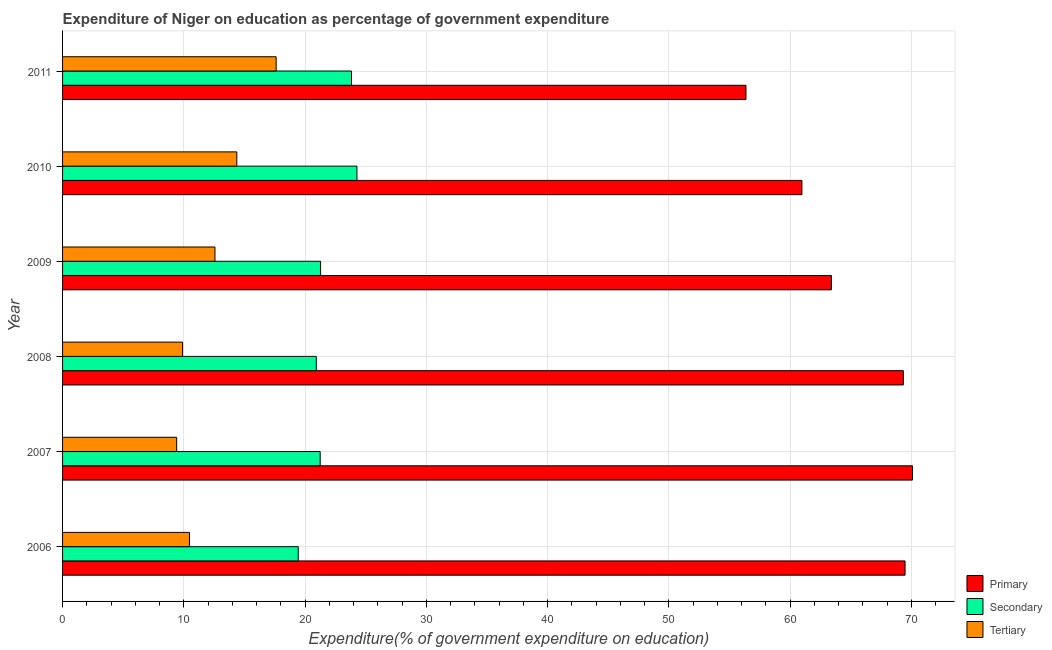Are the number of bars per tick equal to the number of legend labels?
Offer a terse response. Yes. How many bars are there on the 1st tick from the bottom?
Your response must be concise. 3. What is the expenditure on secondary education in 2007?
Your response must be concise. 21.25. Across all years, what is the maximum expenditure on primary education?
Your answer should be very brief. 70.1. Across all years, what is the minimum expenditure on primary education?
Ensure brevity in your answer.  56.36. In which year was the expenditure on primary education minimum?
Provide a succinct answer. 2011. What is the total expenditure on secondary education in the graph?
Your answer should be very brief. 131. What is the difference between the expenditure on secondary education in 2007 and that in 2010?
Your answer should be very brief. -3.03. What is the difference between the expenditure on secondary education in 2006 and the expenditure on primary education in 2010?
Offer a very short reply. -41.54. What is the average expenditure on tertiary education per year?
Provide a short and direct response. 12.39. In the year 2011, what is the difference between the expenditure on secondary education and expenditure on primary education?
Keep it short and to the point. -32.53. In how many years, is the expenditure on tertiary education greater than 38 %?
Give a very brief answer. 0. What is the ratio of the expenditure on secondary education in 2007 to that in 2011?
Your response must be concise. 0.89. Is the difference between the expenditure on primary education in 2009 and 2010 greater than the difference between the expenditure on secondary education in 2009 and 2010?
Give a very brief answer. Yes. What is the difference between the highest and the second highest expenditure on secondary education?
Keep it short and to the point. 0.45. What is the difference between the highest and the lowest expenditure on tertiary education?
Keep it short and to the point. 8.2. Is the sum of the expenditure on primary education in 2006 and 2007 greater than the maximum expenditure on tertiary education across all years?
Offer a very short reply. Yes. What does the 1st bar from the top in 2006 represents?
Keep it short and to the point. Tertiary. What does the 3rd bar from the bottom in 2009 represents?
Provide a short and direct response. Tertiary. Is it the case that in every year, the sum of the expenditure on primary education and expenditure on secondary education is greater than the expenditure on tertiary education?
Offer a terse response. Yes. How many bars are there?
Provide a short and direct response. 18. Are all the bars in the graph horizontal?
Offer a terse response. Yes. What is the difference between two consecutive major ticks on the X-axis?
Ensure brevity in your answer.  10. Are the values on the major ticks of X-axis written in scientific E-notation?
Make the answer very short. No. How many legend labels are there?
Your response must be concise. 3. How are the legend labels stacked?
Keep it short and to the point. Vertical. What is the title of the graph?
Give a very brief answer. Expenditure of Niger on education as percentage of government expenditure. What is the label or title of the X-axis?
Give a very brief answer. Expenditure(% of government expenditure on education). What is the Expenditure(% of government expenditure on education) of Primary in 2006?
Make the answer very short. 69.48. What is the Expenditure(% of government expenditure on education) of Secondary in 2006?
Give a very brief answer. 19.44. What is the Expenditure(% of government expenditure on education) of Tertiary in 2006?
Your response must be concise. 10.47. What is the Expenditure(% of government expenditure on education) of Primary in 2007?
Give a very brief answer. 70.1. What is the Expenditure(% of government expenditure on education) of Secondary in 2007?
Provide a short and direct response. 21.25. What is the Expenditure(% of government expenditure on education) of Tertiary in 2007?
Ensure brevity in your answer.  9.41. What is the Expenditure(% of government expenditure on education) in Primary in 2008?
Offer a terse response. 69.34. What is the Expenditure(% of government expenditure on education) in Secondary in 2008?
Ensure brevity in your answer.  20.93. What is the Expenditure(% of government expenditure on education) in Tertiary in 2008?
Provide a succinct answer. 9.9. What is the Expenditure(% of government expenditure on education) of Primary in 2009?
Make the answer very short. 63.41. What is the Expenditure(% of government expenditure on education) in Secondary in 2009?
Keep it short and to the point. 21.28. What is the Expenditure(% of government expenditure on education) of Tertiary in 2009?
Give a very brief answer. 12.57. What is the Expenditure(% of government expenditure on education) in Primary in 2010?
Your answer should be very brief. 60.98. What is the Expenditure(% of government expenditure on education) in Secondary in 2010?
Provide a short and direct response. 24.28. What is the Expenditure(% of government expenditure on education) in Tertiary in 2010?
Make the answer very short. 14.37. What is the Expenditure(% of government expenditure on education) of Primary in 2011?
Keep it short and to the point. 56.36. What is the Expenditure(% of government expenditure on education) in Secondary in 2011?
Your answer should be very brief. 23.83. What is the Expenditure(% of government expenditure on education) in Tertiary in 2011?
Your answer should be very brief. 17.61. Across all years, what is the maximum Expenditure(% of government expenditure on education) in Primary?
Offer a very short reply. 70.1. Across all years, what is the maximum Expenditure(% of government expenditure on education) of Secondary?
Your answer should be very brief. 24.28. Across all years, what is the maximum Expenditure(% of government expenditure on education) in Tertiary?
Provide a short and direct response. 17.61. Across all years, what is the minimum Expenditure(% of government expenditure on education) in Primary?
Offer a terse response. 56.36. Across all years, what is the minimum Expenditure(% of government expenditure on education) in Secondary?
Your answer should be very brief. 19.44. Across all years, what is the minimum Expenditure(% of government expenditure on education) of Tertiary?
Offer a terse response. 9.41. What is the total Expenditure(% of government expenditure on education) in Primary in the graph?
Your answer should be compact. 389.67. What is the total Expenditure(% of government expenditure on education) of Secondary in the graph?
Your answer should be very brief. 131. What is the total Expenditure(% of government expenditure on education) of Tertiary in the graph?
Make the answer very short. 74.33. What is the difference between the Expenditure(% of government expenditure on education) of Primary in 2006 and that in 2007?
Provide a short and direct response. -0.61. What is the difference between the Expenditure(% of government expenditure on education) in Secondary in 2006 and that in 2007?
Your answer should be compact. -1.81. What is the difference between the Expenditure(% of government expenditure on education) in Tertiary in 2006 and that in 2007?
Your answer should be compact. 1.06. What is the difference between the Expenditure(% of government expenditure on education) in Primary in 2006 and that in 2008?
Your answer should be very brief. 0.14. What is the difference between the Expenditure(% of government expenditure on education) of Secondary in 2006 and that in 2008?
Your response must be concise. -1.49. What is the difference between the Expenditure(% of government expenditure on education) of Tertiary in 2006 and that in 2008?
Keep it short and to the point. 0.57. What is the difference between the Expenditure(% of government expenditure on education) of Primary in 2006 and that in 2009?
Your answer should be compact. 6.07. What is the difference between the Expenditure(% of government expenditure on education) of Secondary in 2006 and that in 2009?
Your response must be concise. -1.84. What is the difference between the Expenditure(% of government expenditure on education) in Tertiary in 2006 and that in 2009?
Your response must be concise. -2.1. What is the difference between the Expenditure(% of government expenditure on education) of Primary in 2006 and that in 2010?
Your answer should be compact. 8.51. What is the difference between the Expenditure(% of government expenditure on education) of Secondary in 2006 and that in 2010?
Your answer should be very brief. -4.84. What is the difference between the Expenditure(% of government expenditure on education) of Tertiary in 2006 and that in 2010?
Provide a short and direct response. -3.9. What is the difference between the Expenditure(% of government expenditure on education) of Primary in 2006 and that in 2011?
Make the answer very short. 13.12. What is the difference between the Expenditure(% of government expenditure on education) of Secondary in 2006 and that in 2011?
Your answer should be compact. -4.39. What is the difference between the Expenditure(% of government expenditure on education) in Tertiary in 2006 and that in 2011?
Your answer should be compact. -7.15. What is the difference between the Expenditure(% of government expenditure on education) of Primary in 2007 and that in 2008?
Ensure brevity in your answer.  0.75. What is the difference between the Expenditure(% of government expenditure on education) of Secondary in 2007 and that in 2008?
Offer a very short reply. 0.32. What is the difference between the Expenditure(% of government expenditure on education) of Tertiary in 2007 and that in 2008?
Your answer should be very brief. -0.49. What is the difference between the Expenditure(% of government expenditure on education) of Primary in 2007 and that in 2009?
Keep it short and to the point. 6.68. What is the difference between the Expenditure(% of government expenditure on education) in Secondary in 2007 and that in 2009?
Provide a succinct answer. -0.03. What is the difference between the Expenditure(% of government expenditure on education) in Tertiary in 2007 and that in 2009?
Make the answer very short. -3.16. What is the difference between the Expenditure(% of government expenditure on education) in Primary in 2007 and that in 2010?
Your answer should be compact. 9.12. What is the difference between the Expenditure(% of government expenditure on education) in Secondary in 2007 and that in 2010?
Offer a terse response. -3.03. What is the difference between the Expenditure(% of government expenditure on education) of Tertiary in 2007 and that in 2010?
Make the answer very short. -4.96. What is the difference between the Expenditure(% of government expenditure on education) of Primary in 2007 and that in 2011?
Keep it short and to the point. 13.73. What is the difference between the Expenditure(% of government expenditure on education) of Secondary in 2007 and that in 2011?
Your answer should be very brief. -2.58. What is the difference between the Expenditure(% of government expenditure on education) in Tertiary in 2007 and that in 2011?
Your answer should be very brief. -8.2. What is the difference between the Expenditure(% of government expenditure on education) of Primary in 2008 and that in 2009?
Provide a short and direct response. 5.93. What is the difference between the Expenditure(% of government expenditure on education) of Secondary in 2008 and that in 2009?
Your answer should be compact. -0.35. What is the difference between the Expenditure(% of government expenditure on education) of Tertiary in 2008 and that in 2009?
Offer a very short reply. -2.67. What is the difference between the Expenditure(% of government expenditure on education) in Primary in 2008 and that in 2010?
Give a very brief answer. 8.36. What is the difference between the Expenditure(% of government expenditure on education) in Secondary in 2008 and that in 2010?
Provide a short and direct response. -3.35. What is the difference between the Expenditure(% of government expenditure on education) of Tertiary in 2008 and that in 2010?
Provide a short and direct response. -4.47. What is the difference between the Expenditure(% of government expenditure on education) in Primary in 2008 and that in 2011?
Keep it short and to the point. 12.98. What is the difference between the Expenditure(% of government expenditure on education) in Secondary in 2008 and that in 2011?
Offer a very short reply. -2.9. What is the difference between the Expenditure(% of government expenditure on education) of Tertiary in 2008 and that in 2011?
Keep it short and to the point. -7.72. What is the difference between the Expenditure(% of government expenditure on education) in Primary in 2009 and that in 2010?
Provide a succinct answer. 2.43. What is the difference between the Expenditure(% of government expenditure on education) in Secondary in 2009 and that in 2010?
Give a very brief answer. -3. What is the difference between the Expenditure(% of government expenditure on education) of Tertiary in 2009 and that in 2010?
Offer a very short reply. -1.8. What is the difference between the Expenditure(% of government expenditure on education) in Primary in 2009 and that in 2011?
Give a very brief answer. 7.05. What is the difference between the Expenditure(% of government expenditure on education) in Secondary in 2009 and that in 2011?
Offer a very short reply. -2.55. What is the difference between the Expenditure(% of government expenditure on education) in Tertiary in 2009 and that in 2011?
Offer a terse response. -5.05. What is the difference between the Expenditure(% of government expenditure on education) in Primary in 2010 and that in 2011?
Offer a very short reply. 4.62. What is the difference between the Expenditure(% of government expenditure on education) of Secondary in 2010 and that in 2011?
Provide a succinct answer. 0.45. What is the difference between the Expenditure(% of government expenditure on education) in Tertiary in 2010 and that in 2011?
Offer a terse response. -3.24. What is the difference between the Expenditure(% of government expenditure on education) in Primary in 2006 and the Expenditure(% of government expenditure on education) in Secondary in 2007?
Your answer should be very brief. 48.24. What is the difference between the Expenditure(% of government expenditure on education) in Primary in 2006 and the Expenditure(% of government expenditure on education) in Tertiary in 2007?
Offer a terse response. 60.07. What is the difference between the Expenditure(% of government expenditure on education) in Secondary in 2006 and the Expenditure(% of government expenditure on education) in Tertiary in 2007?
Your answer should be very brief. 10.03. What is the difference between the Expenditure(% of government expenditure on education) of Primary in 2006 and the Expenditure(% of government expenditure on education) of Secondary in 2008?
Your answer should be compact. 48.56. What is the difference between the Expenditure(% of government expenditure on education) in Primary in 2006 and the Expenditure(% of government expenditure on education) in Tertiary in 2008?
Provide a short and direct response. 59.59. What is the difference between the Expenditure(% of government expenditure on education) in Secondary in 2006 and the Expenditure(% of government expenditure on education) in Tertiary in 2008?
Offer a very short reply. 9.54. What is the difference between the Expenditure(% of government expenditure on education) of Primary in 2006 and the Expenditure(% of government expenditure on education) of Secondary in 2009?
Keep it short and to the point. 48.2. What is the difference between the Expenditure(% of government expenditure on education) of Primary in 2006 and the Expenditure(% of government expenditure on education) of Tertiary in 2009?
Offer a terse response. 56.92. What is the difference between the Expenditure(% of government expenditure on education) in Secondary in 2006 and the Expenditure(% of government expenditure on education) in Tertiary in 2009?
Your answer should be very brief. 6.87. What is the difference between the Expenditure(% of government expenditure on education) of Primary in 2006 and the Expenditure(% of government expenditure on education) of Secondary in 2010?
Ensure brevity in your answer.  45.21. What is the difference between the Expenditure(% of government expenditure on education) in Primary in 2006 and the Expenditure(% of government expenditure on education) in Tertiary in 2010?
Make the answer very short. 55.12. What is the difference between the Expenditure(% of government expenditure on education) in Secondary in 2006 and the Expenditure(% of government expenditure on education) in Tertiary in 2010?
Offer a very short reply. 5.07. What is the difference between the Expenditure(% of government expenditure on education) of Primary in 2006 and the Expenditure(% of government expenditure on education) of Secondary in 2011?
Keep it short and to the point. 45.66. What is the difference between the Expenditure(% of government expenditure on education) in Primary in 2006 and the Expenditure(% of government expenditure on education) in Tertiary in 2011?
Your response must be concise. 51.87. What is the difference between the Expenditure(% of government expenditure on education) of Secondary in 2006 and the Expenditure(% of government expenditure on education) of Tertiary in 2011?
Keep it short and to the point. 1.82. What is the difference between the Expenditure(% of government expenditure on education) of Primary in 2007 and the Expenditure(% of government expenditure on education) of Secondary in 2008?
Your answer should be compact. 49.17. What is the difference between the Expenditure(% of government expenditure on education) in Primary in 2007 and the Expenditure(% of government expenditure on education) in Tertiary in 2008?
Offer a terse response. 60.2. What is the difference between the Expenditure(% of government expenditure on education) in Secondary in 2007 and the Expenditure(% of government expenditure on education) in Tertiary in 2008?
Your answer should be very brief. 11.35. What is the difference between the Expenditure(% of government expenditure on education) of Primary in 2007 and the Expenditure(% of government expenditure on education) of Secondary in 2009?
Your response must be concise. 48.82. What is the difference between the Expenditure(% of government expenditure on education) in Primary in 2007 and the Expenditure(% of government expenditure on education) in Tertiary in 2009?
Give a very brief answer. 57.53. What is the difference between the Expenditure(% of government expenditure on education) in Secondary in 2007 and the Expenditure(% of government expenditure on education) in Tertiary in 2009?
Offer a very short reply. 8.68. What is the difference between the Expenditure(% of government expenditure on education) of Primary in 2007 and the Expenditure(% of government expenditure on education) of Secondary in 2010?
Keep it short and to the point. 45.82. What is the difference between the Expenditure(% of government expenditure on education) in Primary in 2007 and the Expenditure(% of government expenditure on education) in Tertiary in 2010?
Keep it short and to the point. 55.73. What is the difference between the Expenditure(% of government expenditure on education) in Secondary in 2007 and the Expenditure(% of government expenditure on education) in Tertiary in 2010?
Ensure brevity in your answer.  6.88. What is the difference between the Expenditure(% of government expenditure on education) in Primary in 2007 and the Expenditure(% of government expenditure on education) in Secondary in 2011?
Keep it short and to the point. 46.27. What is the difference between the Expenditure(% of government expenditure on education) in Primary in 2007 and the Expenditure(% of government expenditure on education) in Tertiary in 2011?
Provide a succinct answer. 52.48. What is the difference between the Expenditure(% of government expenditure on education) of Secondary in 2007 and the Expenditure(% of government expenditure on education) of Tertiary in 2011?
Your answer should be very brief. 3.63. What is the difference between the Expenditure(% of government expenditure on education) of Primary in 2008 and the Expenditure(% of government expenditure on education) of Secondary in 2009?
Keep it short and to the point. 48.06. What is the difference between the Expenditure(% of government expenditure on education) in Primary in 2008 and the Expenditure(% of government expenditure on education) in Tertiary in 2009?
Your answer should be compact. 56.77. What is the difference between the Expenditure(% of government expenditure on education) in Secondary in 2008 and the Expenditure(% of government expenditure on education) in Tertiary in 2009?
Offer a very short reply. 8.36. What is the difference between the Expenditure(% of government expenditure on education) in Primary in 2008 and the Expenditure(% of government expenditure on education) in Secondary in 2010?
Keep it short and to the point. 45.06. What is the difference between the Expenditure(% of government expenditure on education) in Primary in 2008 and the Expenditure(% of government expenditure on education) in Tertiary in 2010?
Your response must be concise. 54.97. What is the difference between the Expenditure(% of government expenditure on education) of Secondary in 2008 and the Expenditure(% of government expenditure on education) of Tertiary in 2010?
Your answer should be very brief. 6.56. What is the difference between the Expenditure(% of government expenditure on education) of Primary in 2008 and the Expenditure(% of government expenditure on education) of Secondary in 2011?
Offer a terse response. 45.51. What is the difference between the Expenditure(% of government expenditure on education) of Primary in 2008 and the Expenditure(% of government expenditure on education) of Tertiary in 2011?
Make the answer very short. 51.73. What is the difference between the Expenditure(% of government expenditure on education) of Secondary in 2008 and the Expenditure(% of government expenditure on education) of Tertiary in 2011?
Give a very brief answer. 3.31. What is the difference between the Expenditure(% of government expenditure on education) in Primary in 2009 and the Expenditure(% of government expenditure on education) in Secondary in 2010?
Ensure brevity in your answer.  39.13. What is the difference between the Expenditure(% of government expenditure on education) in Primary in 2009 and the Expenditure(% of government expenditure on education) in Tertiary in 2010?
Ensure brevity in your answer.  49.04. What is the difference between the Expenditure(% of government expenditure on education) in Secondary in 2009 and the Expenditure(% of government expenditure on education) in Tertiary in 2010?
Ensure brevity in your answer.  6.91. What is the difference between the Expenditure(% of government expenditure on education) of Primary in 2009 and the Expenditure(% of government expenditure on education) of Secondary in 2011?
Give a very brief answer. 39.58. What is the difference between the Expenditure(% of government expenditure on education) of Primary in 2009 and the Expenditure(% of government expenditure on education) of Tertiary in 2011?
Ensure brevity in your answer.  45.8. What is the difference between the Expenditure(% of government expenditure on education) of Secondary in 2009 and the Expenditure(% of government expenditure on education) of Tertiary in 2011?
Offer a terse response. 3.67. What is the difference between the Expenditure(% of government expenditure on education) of Primary in 2010 and the Expenditure(% of government expenditure on education) of Secondary in 2011?
Give a very brief answer. 37.15. What is the difference between the Expenditure(% of government expenditure on education) of Primary in 2010 and the Expenditure(% of government expenditure on education) of Tertiary in 2011?
Your answer should be compact. 43.36. What is the difference between the Expenditure(% of government expenditure on education) in Secondary in 2010 and the Expenditure(% of government expenditure on education) in Tertiary in 2011?
Your answer should be very brief. 6.66. What is the average Expenditure(% of government expenditure on education) of Primary per year?
Make the answer very short. 64.95. What is the average Expenditure(% of government expenditure on education) in Secondary per year?
Your answer should be compact. 21.83. What is the average Expenditure(% of government expenditure on education) in Tertiary per year?
Your answer should be compact. 12.39. In the year 2006, what is the difference between the Expenditure(% of government expenditure on education) in Primary and Expenditure(% of government expenditure on education) in Secondary?
Make the answer very short. 50.05. In the year 2006, what is the difference between the Expenditure(% of government expenditure on education) in Primary and Expenditure(% of government expenditure on education) in Tertiary?
Offer a very short reply. 59.02. In the year 2006, what is the difference between the Expenditure(% of government expenditure on education) of Secondary and Expenditure(% of government expenditure on education) of Tertiary?
Ensure brevity in your answer.  8.97. In the year 2007, what is the difference between the Expenditure(% of government expenditure on education) of Primary and Expenditure(% of government expenditure on education) of Secondary?
Provide a short and direct response. 48.85. In the year 2007, what is the difference between the Expenditure(% of government expenditure on education) of Primary and Expenditure(% of government expenditure on education) of Tertiary?
Offer a very short reply. 60.68. In the year 2007, what is the difference between the Expenditure(% of government expenditure on education) of Secondary and Expenditure(% of government expenditure on education) of Tertiary?
Ensure brevity in your answer.  11.84. In the year 2008, what is the difference between the Expenditure(% of government expenditure on education) of Primary and Expenditure(% of government expenditure on education) of Secondary?
Ensure brevity in your answer.  48.42. In the year 2008, what is the difference between the Expenditure(% of government expenditure on education) in Primary and Expenditure(% of government expenditure on education) in Tertiary?
Give a very brief answer. 59.44. In the year 2008, what is the difference between the Expenditure(% of government expenditure on education) of Secondary and Expenditure(% of government expenditure on education) of Tertiary?
Ensure brevity in your answer.  11.03. In the year 2009, what is the difference between the Expenditure(% of government expenditure on education) of Primary and Expenditure(% of government expenditure on education) of Secondary?
Give a very brief answer. 42.13. In the year 2009, what is the difference between the Expenditure(% of government expenditure on education) in Primary and Expenditure(% of government expenditure on education) in Tertiary?
Offer a very short reply. 50.84. In the year 2009, what is the difference between the Expenditure(% of government expenditure on education) of Secondary and Expenditure(% of government expenditure on education) of Tertiary?
Provide a succinct answer. 8.71. In the year 2010, what is the difference between the Expenditure(% of government expenditure on education) in Primary and Expenditure(% of government expenditure on education) in Secondary?
Offer a terse response. 36.7. In the year 2010, what is the difference between the Expenditure(% of government expenditure on education) in Primary and Expenditure(% of government expenditure on education) in Tertiary?
Keep it short and to the point. 46.61. In the year 2010, what is the difference between the Expenditure(% of government expenditure on education) of Secondary and Expenditure(% of government expenditure on education) of Tertiary?
Keep it short and to the point. 9.91. In the year 2011, what is the difference between the Expenditure(% of government expenditure on education) of Primary and Expenditure(% of government expenditure on education) of Secondary?
Ensure brevity in your answer.  32.53. In the year 2011, what is the difference between the Expenditure(% of government expenditure on education) of Primary and Expenditure(% of government expenditure on education) of Tertiary?
Your answer should be compact. 38.75. In the year 2011, what is the difference between the Expenditure(% of government expenditure on education) in Secondary and Expenditure(% of government expenditure on education) in Tertiary?
Provide a short and direct response. 6.22. What is the ratio of the Expenditure(% of government expenditure on education) in Primary in 2006 to that in 2007?
Give a very brief answer. 0.99. What is the ratio of the Expenditure(% of government expenditure on education) in Secondary in 2006 to that in 2007?
Your answer should be very brief. 0.91. What is the ratio of the Expenditure(% of government expenditure on education) of Tertiary in 2006 to that in 2007?
Offer a very short reply. 1.11. What is the ratio of the Expenditure(% of government expenditure on education) in Primary in 2006 to that in 2008?
Provide a succinct answer. 1. What is the ratio of the Expenditure(% of government expenditure on education) of Secondary in 2006 to that in 2008?
Keep it short and to the point. 0.93. What is the ratio of the Expenditure(% of government expenditure on education) of Tertiary in 2006 to that in 2008?
Your response must be concise. 1.06. What is the ratio of the Expenditure(% of government expenditure on education) in Primary in 2006 to that in 2009?
Keep it short and to the point. 1.1. What is the ratio of the Expenditure(% of government expenditure on education) in Secondary in 2006 to that in 2009?
Make the answer very short. 0.91. What is the ratio of the Expenditure(% of government expenditure on education) in Tertiary in 2006 to that in 2009?
Ensure brevity in your answer.  0.83. What is the ratio of the Expenditure(% of government expenditure on education) of Primary in 2006 to that in 2010?
Offer a terse response. 1.14. What is the ratio of the Expenditure(% of government expenditure on education) in Secondary in 2006 to that in 2010?
Make the answer very short. 0.8. What is the ratio of the Expenditure(% of government expenditure on education) in Tertiary in 2006 to that in 2010?
Keep it short and to the point. 0.73. What is the ratio of the Expenditure(% of government expenditure on education) of Primary in 2006 to that in 2011?
Your answer should be compact. 1.23. What is the ratio of the Expenditure(% of government expenditure on education) of Secondary in 2006 to that in 2011?
Provide a short and direct response. 0.82. What is the ratio of the Expenditure(% of government expenditure on education) of Tertiary in 2006 to that in 2011?
Your answer should be very brief. 0.59. What is the ratio of the Expenditure(% of government expenditure on education) in Primary in 2007 to that in 2008?
Provide a short and direct response. 1.01. What is the ratio of the Expenditure(% of government expenditure on education) in Secondary in 2007 to that in 2008?
Offer a very short reply. 1.02. What is the ratio of the Expenditure(% of government expenditure on education) in Tertiary in 2007 to that in 2008?
Provide a short and direct response. 0.95. What is the ratio of the Expenditure(% of government expenditure on education) in Primary in 2007 to that in 2009?
Provide a short and direct response. 1.11. What is the ratio of the Expenditure(% of government expenditure on education) in Tertiary in 2007 to that in 2009?
Provide a short and direct response. 0.75. What is the ratio of the Expenditure(% of government expenditure on education) in Primary in 2007 to that in 2010?
Make the answer very short. 1.15. What is the ratio of the Expenditure(% of government expenditure on education) in Secondary in 2007 to that in 2010?
Provide a succinct answer. 0.88. What is the ratio of the Expenditure(% of government expenditure on education) in Tertiary in 2007 to that in 2010?
Keep it short and to the point. 0.65. What is the ratio of the Expenditure(% of government expenditure on education) in Primary in 2007 to that in 2011?
Your answer should be very brief. 1.24. What is the ratio of the Expenditure(% of government expenditure on education) in Secondary in 2007 to that in 2011?
Provide a short and direct response. 0.89. What is the ratio of the Expenditure(% of government expenditure on education) in Tertiary in 2007 to that in 2011?
Your answer should be very brief. 0.53. What is the ratio of the Expenditure(% of government expenditure on education) in Primary in 2008 to that in 2009?
Offer a very short reply. 1.09. What is the ratio of the Expenditure(% of government expenditure on education) of Secondary in 2008 to that in 2009?
Offer a terse response. 0.98. What is the ratio of the Expenditure(% of government expenditure on education) in Tertiary in 2008 to that in 2009?
Your answer should be compact. 0.79. What is the ratio of the Expenditure(% of government expenditure on education) in Primary in 2008 to that in 2010?
Your answer should be compact. 1.14. What is the ratio of the Expenditure(% of government expenditure on education) in Secondary in 2008 to that in 2010?
Ensure brevity in your answer.  0.86. What is the ratio of the Expenditure(% of government expenditure on education) of Tertiary in 2008 to that in 2010?
Offer a terse response. 0.69. What is the ratio of the Expenditure(% of government expenditure on education) in Primary in 2008 to that in 2011?
Offer a very short reply. 1.23. What is the ratio of the Expenditure(% of government expenditure on education) in Secondary in 2008 to that in 2011?
Provide a short and direct response. 0.88. What is the ratio of the Expenditure(% of government expenditure on education) of Tertiary in 2008 to that in 2011?
Keep it short and to the point. 0.56. What is the ratio of the Expenditure(% of government expenditure on education) in Primary in 2009 to that in 2010?
Make the answer very short. 1.04. What is the ratio of the Expenditure(% of government expenditure on education) in Secondary in 2009 to that in 2010?
Offer a terse response. 0.88. What is the ratio of the Expenditure(% of government expenditure on education) of Tertiary in 2009 to that in 2010?
Offer a very short reply. 0.87. What is the ratio of the Expenditure(% of government expenditure on education) of Primary in 2009 to that in 2011?
Provide a short and direct response. 1.13. What is the ratio of the Expenditure(% of government expenditure on education) in Secondary in 2009 to that in 2011?
Provide a short and direct response. 0.89. What is the ratio of the Expenditure(% of government expenditure on education) of Tertiary in 2009 to that in 2011?
Provide a succinct answer. 0.71. What is the ratio of the Expenditure(% of government expenditure on education) in Primary in 2010 to that in 2011?
Your answer should be very brief. 1.08. What is the ratio of the Expenditure(% of government expenditure on education) in Secondary in 2010 to that in 2011?
Your answer should be compact. 1.02. What is the ratio of the Expenditure(% of government expenditure on education) of Tertiary in 2010 to that in 2011?
Offer a very short reply. 0.82. What is the difference between the highest and the second highest Expenditure(% of government expenditure on education) in Primary?
Offer a very short reply. 0.61. What is the difference between the highest and the second highest Expenditure(% of government expenditure on education) in Secondary?
Your answer should be very brief. 0.45. What is the difference between the highest and the second highest Expenditure(% of government expenditure on education) in Tertiary?
Give a very brief answer. 3.24. What is the difference between the highest and the lowest Expenditure(% of government expenditure on education) of Primary?
Keep it short and to the point. 13.73. What is the difference between the highest and the lowest Expenditure(% of government expenditure on education) of Secondary?
Provide a short and direct response. 4.84. What is the difference between the highest and the lowest Expenditure(% of government expenditure on education) of Tertiary?
Make the answer very short. 8.2. 